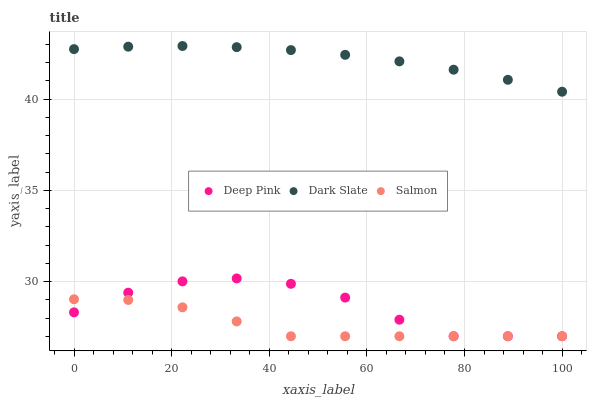Does Salmon have the minimum area under the curve?
Answer yes or no. Yes. Does Dark Slate have the maximum area under the curve?
Answer yes or no. Yes. Does Deep Pink have the minimum area under the curve?
Answer yes or no. No. Does Deep Pink have the maximum area under the curve?
Answer yes or no. No. Is Dark Slate the smoothest?
Answer yes or no. Yes. Is Deep Pink the roughest?
Answer yes or no. Yes. Is Salmon the smoothest?
Answer yes or no. No. Is Salmon the roughest?
Answer yes or no. No. Does Deep Pink have the lowest value?
Answer yes or no. Yes. Does Dark Slate have the highest value?
Answer yes or no. Yes. Does Deep Pink have the highest value?
Answer yes or no. No. Is Deep Pink less than Dark Slate?
Answer yes or no. Yes. Is Dark Slate greater than Deep Pink?
Answer yes or no. Yes. Does Salmon intersect Deep Pink?
Answer yes or no. Yes. Is Salmon less than Deep Pink?
Answer yes or no. No. Is Salmon greater than Deep Pink?
Answer yes or no. No. Does Deep Pink intersect Dark Slate?
Answer yes or no. No. 